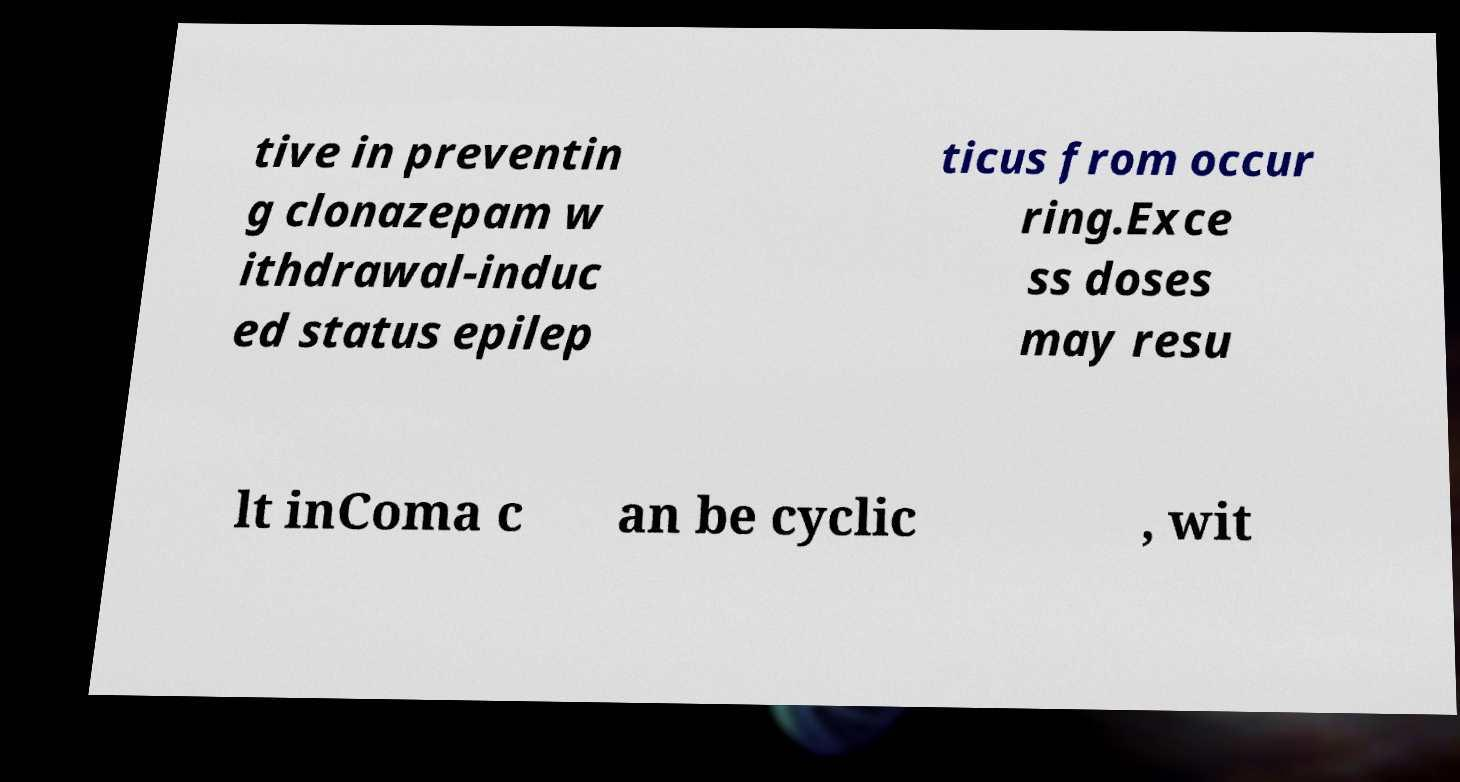For documentation purposes, I need the text within this image transcribed. Could you provide that? tive in preventin g clonazepam w ithdrawal-induc ed status epilep ticus from occur ring.Exce ss doses may resu lt inComa c an be cyclic , wit 